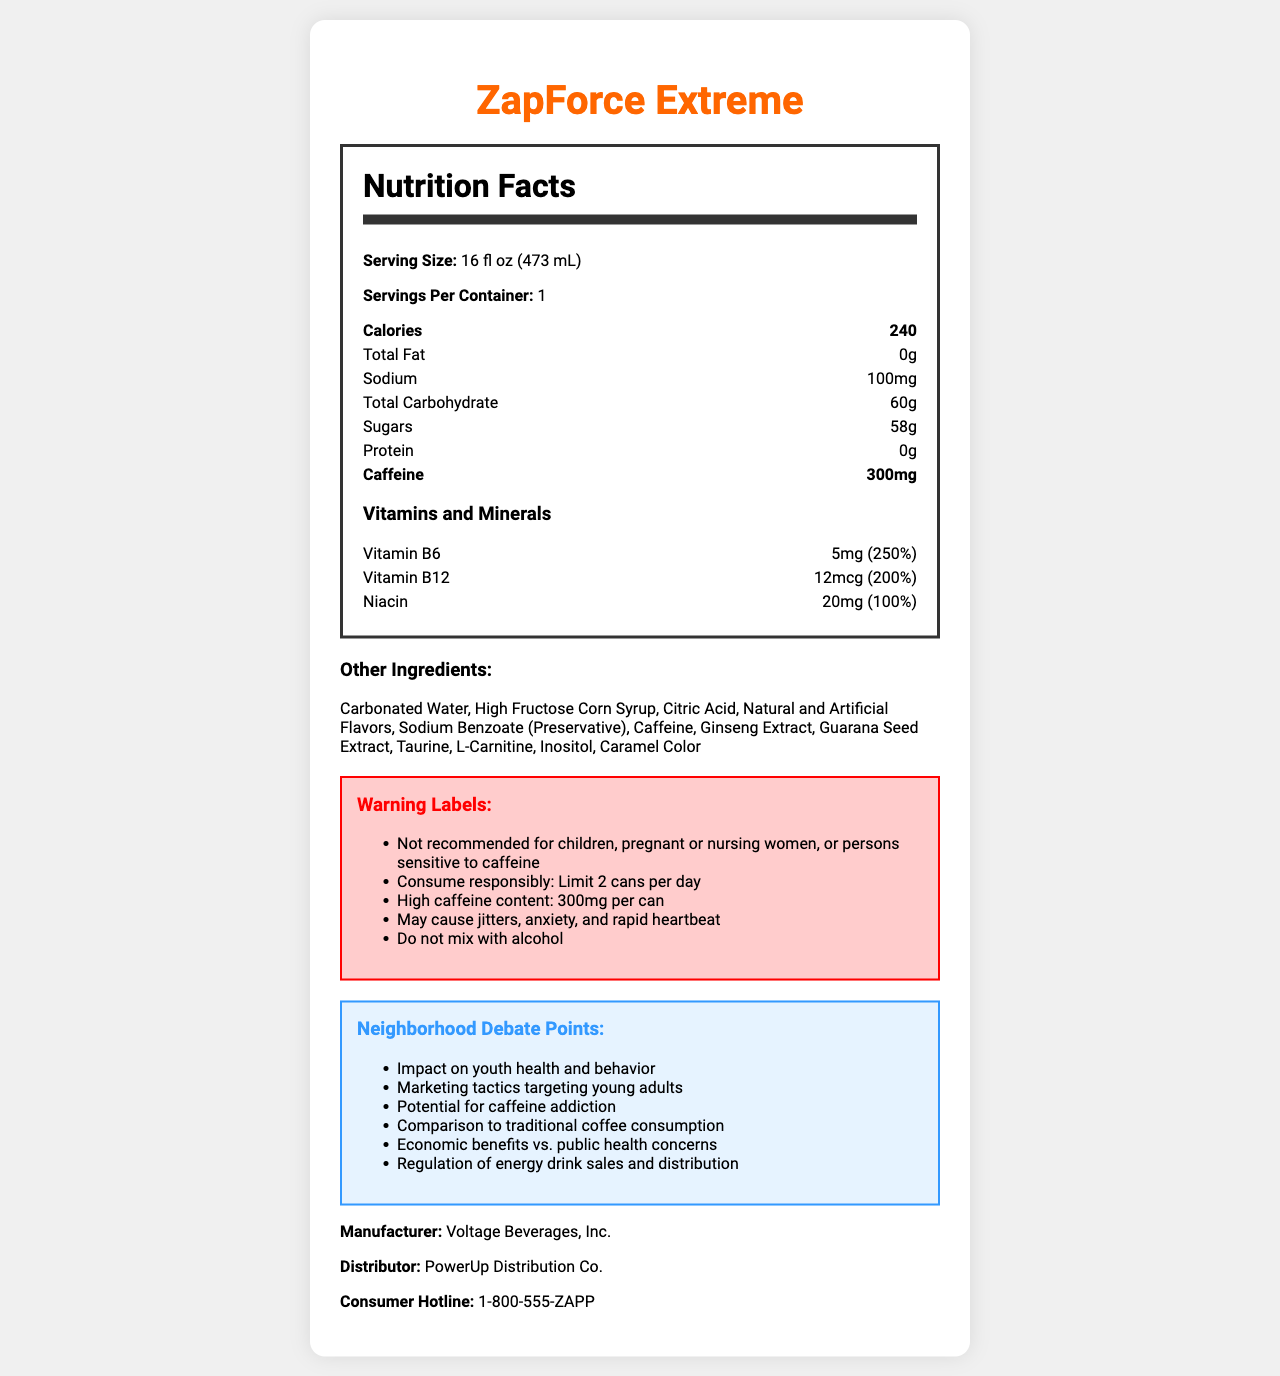what is the serving size of ZapForce Extreme? The serving size is explicitly mentioned in the nutrition facts section as 16 fl oz (473 mL).
Answer: 16 fl oz (473 mL) How much caffeine does one can of ZapForce Extreme contain? The caffeine content is mentioned in the nutrition facts as 300mg per can.
Answer: 300mg Name one ingredient in ZapForce Extreme other than caffeine. One of the other ingredients listed is High Fructose Corn Syrup.
Answer: High Fructose Corn Syrup What is the calorie count per serving of this energy drink? The document states that the calorie count per serving is 240.
Answer: 240 List two vitamins or minerals found in ZapForce Extreme. The vitamins and minerals listed include Vitamin B6 and Vitamin B12.
Answer: Vitamin B6, Vitamin B12 What is the warning about caffeine in ZapForce Extreme? A. "Low caffeine content" B. "Moderate caffeine content" C. "High caffeine content" The warning labels indicate that the beverage has a "High caffeine content: 300mg per can".
Answer: C How many servings are there per container of ZapForce Extreme? A. 1 B. 2 C. 3 The document specifies that there is 1 serving per container.
Answer: A Can children consume ZapForce Extreme? Yes/No The document has a warning label stating that the drink is not recommended for children, pregnant or nursing women, or persons sensitive to caffeine.
Answer: No Summarize the key points of the ZapForce Extreme Nutrition Facts document. The detailed summary includes the product name, nutritional content, caffeine warning, sugar content, vitamins included, and the main areas of concern noted in the document.
Answer: ZapForce Extreme is an energy drink with 240 calories per 16 fl oz (473 mL) serving. It contains high levels of caffeine (300mg), sugar (58g), and certain vitamins like Vitamin B6 and B12. The document includes various warning labels about the potential health risks and consumption limits. There are debate points about its impact on youth health and marketing tactics. What is the total amount of protein in ZapForce Extreme? The nutrition facts section clearly states that there is 0g of protein.
Answer: 0g Who is the distributor of ZapForce Extreme? The distributor is listed at the bottom of the document as PowerUp Distribution Co.
Answer: PowerUp Distribution Co. What are some potential health concerns associated with consuming ZapForce Extreme? The warning labels mention that the energy drink may cause jitters, anxiety, and rapid heartbeat.
Answer: Jitters, anxiety, rapid heartbeat What are the marketing tactics that might target young adults as mentioned in the debate points? The document does not provide specific details about the marketing tactics, only mentions it as a debate point.
Answer: I don't know Why might there be economic benefits associated with the sale of ZapForce Extreme? The debate points mention economic benefits vs. public health concerns but do not provide specific details about the economic benefits.
Answer: The document includes this as a debate point, but does not provide details. 